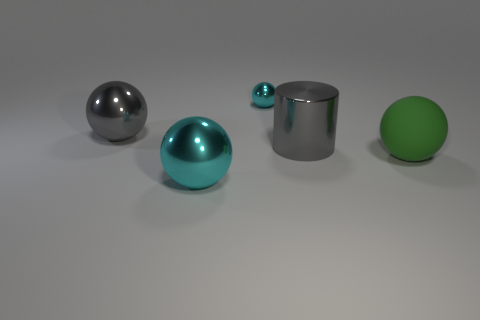Is the cyan object in front of the large green matte sphere made of the same material as the large gray object to the left of the small metallic ball?
Provide a succinct answer. Yes. The cyan metallic object in front of the cyan shiny sphere that is behind the green matte ball is what shape?
Ensure brevity in your answer.  Sphere. What color is the small ball that is made of the same material as the big cylinder?
Ensure brevity in your answer.  Cyan. Is the color of the metallic cylinder the same as the small metal thing?
Give a very brief answer. No. There is a gray thing that is the same size as the gray ball; what is its shape?
Offer a terse response. Cylinder. What size is the gray cylinder?
Provide a succinct answer. Large. Does the cyan shiny ball that is to the right of the big cyan object have the same size as the gray metal thing behind the metal cylinder?
Your answer should be compact. No. The metal object in front of the sphere on the right side of the tiny cyan metallic object is what color?
Provide a succinct answer. Cyan. What material is the green sphere that is the same size as the cylinder?
Give a very brief answer. Rubber. What number of rubber things are tiny cyan objects or small brown things?
Keep it short and to the point. 0. 